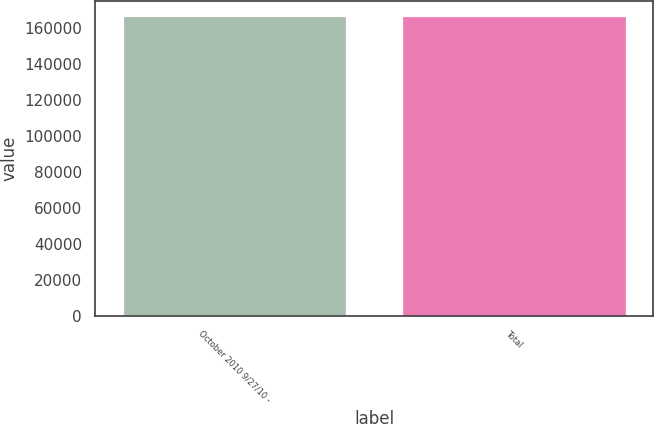<chart> <loc_0><loc_0><loc_500><loc_500><bar_chart><fcel>October 2010 9/27/10 -<fcel>Total<nl><fcel>166572<fcel>166572<nl></chart> 